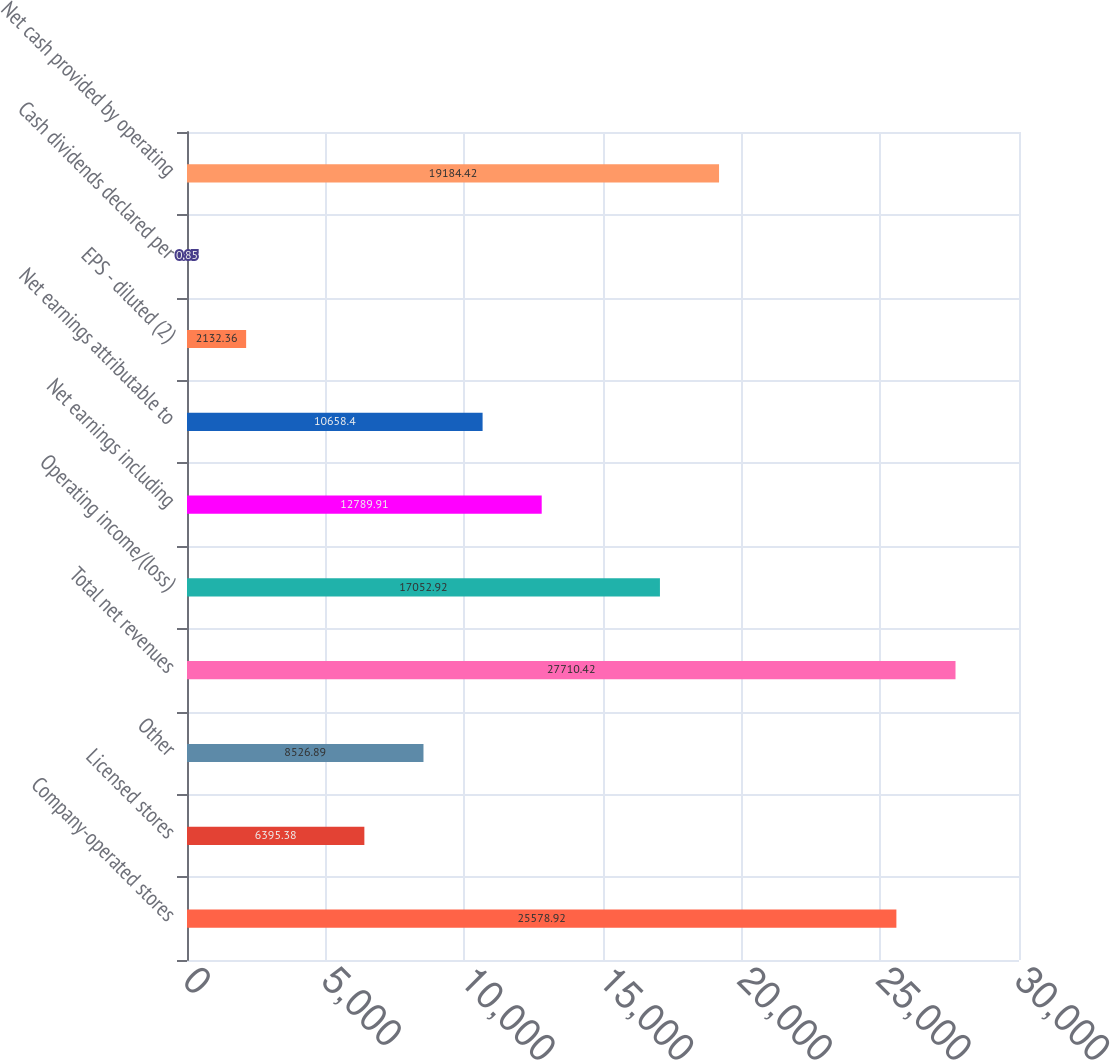Convert chart to OTSL. <chart><loc_0><loc_0><loc_500><loc_500><bar_chart><fcel>Company-operated stores<fcel>Licensed stores<fcel>Other<fcel>Total net revenues<fcel>Operating income/(loss)<fcel>Net earnings including<fcel>Net earnings attributable to<fcel>EPS - diluted (2)<fcel>Cash dividends declared per<fcel>Net cash provided by operating<nl><fcel>25578.9<fcel>6395.38<fcel>8526.89<fcel>27710.4<fcel>17052.9<fcel>12789.9<fcel>10658.4<fcel>2132.36<fcel>0.85<fcel>19184.4<nl></chart> 